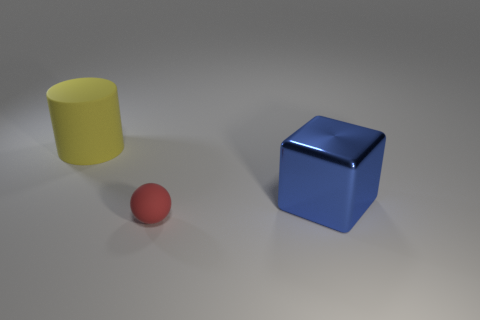Add 2 blue cubes. How many objects exist? 5 Subtract all cylinders. How many objects are left? 2 Subtract all green shiny spheres. Subtract all rubber things. How many objects are left? 1 Add 3 red balls. How many red balls are left? 4 Add 1 large metal blocks. How many large metal blocks exist? 2 Subtract 0 cyan spheres. How many objects are left? 3 